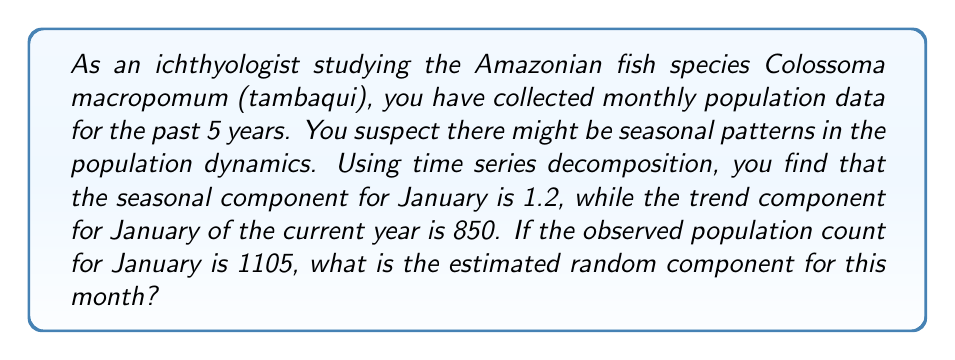Provide a solution to this math problem. To solve this problem, we need to understand the components of time series decomposition and how they relate to each other. In a multiplicative time series model, we have:

$$\text{Observed} = \text{Trend} \times \text{Seasonal} \times \text{Random}$$

Let's break down the solution step by step:

1) We are given:
   - Observed value (O) = 1105
   - Trend component (T) = 850
   - Seasonal component (S) = 1.2

2) We need to find the Random component (R). Rearranging the equation:

   $$R = \frac{O}{T \times S}$$

3) Substituting the known values:

   $$R = \frac{1105}{850 \times 1.2}$$

4) Calculate:
   
   $$R = \frac{1105}{1020} \approx 1.0833$$

5) Typically, we round the random component to three decimal places:

   $$R \approx 1.083$$

This means that the random component for January is slightly above 1, indicating a small positive random fluctuation in the population for this month.
Answer: The estimated random component for January is approximately 1.083. 